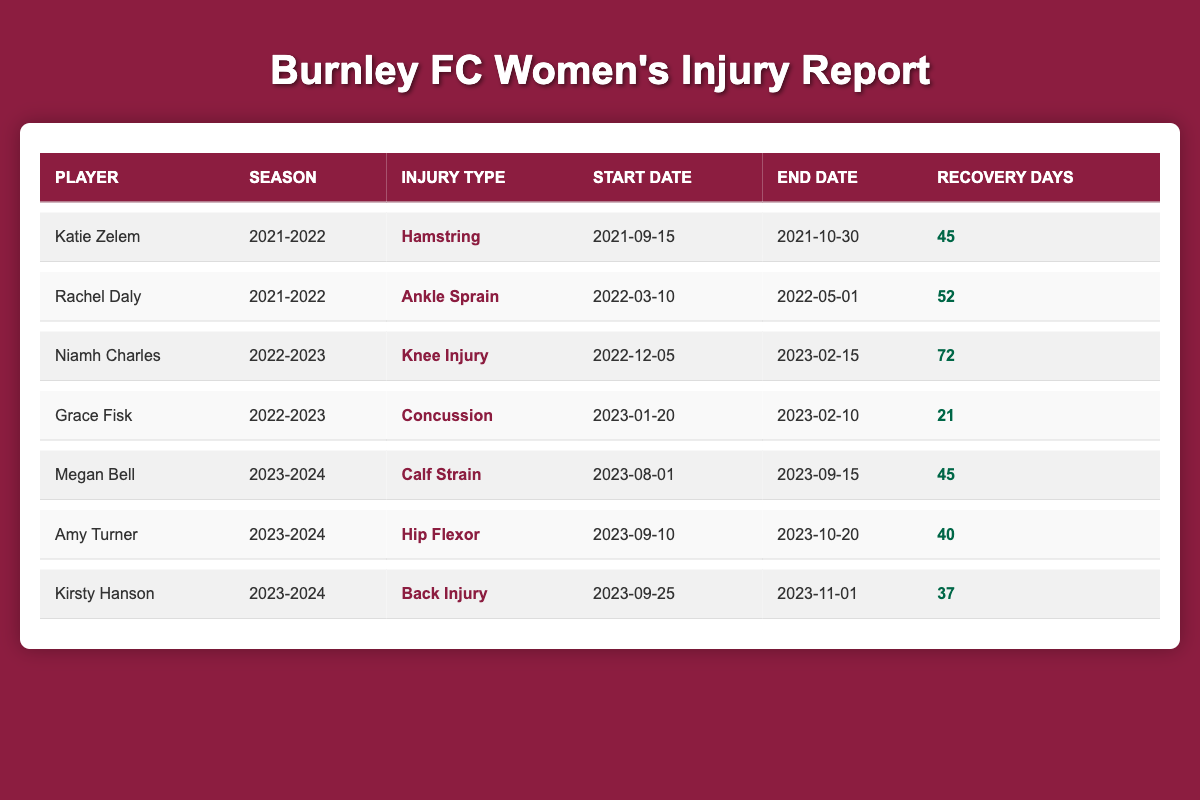What was the injury type for Niamh Charles in the 2022-2023 season? According to the table, Niamh Charles had a Knee Injury as noted under the "Injury Type" column for the 2022-2023 season.
Answer: Knee Injury How many recovery days did Amy Turner have for her injury? The table shows that Amy Turner had a total of 40 recovery days listed under the "Recovery Days" column for her Hip Flexor injury.
Answer: 40 Which player had the longest recovery time in the 2022-2023 season? Niamh Charles had 72 recovery days due to a Knee Injury, which is longer than any other player in the 2022-2023 season, making her the player with the longest recovery time.
Answer: Niamh Charles Is Rachel Daly's injury type classified as a sprain? Yes, Rachel Daly's injury type is mentioned in the table as "Ankle Sprain," which confirms that it is classified as a sprain.
Answer: Yes What is the total recovery time for all players from the 2023-2024 season? Adding the recovery days for all players in the 2023-2024 season: 45 (Megan Bell) + 40 (Amy Turner) + 37 (Kirsty Hanson) = 122, so the total recovery time is 122 days.
Answer: 122 What is the difference in recovery days between Katie Zelem and Rachel Daly? Katie Zelem had 45 recovery days while Rachel Daly had 52 recovery days. To find the difference, we subtract: 52 - 45 = 7 days.
Answer: 7 What was the average recovery time for the injuries listed in the 2021-2022 season? For the 2021-2022 season, the recovery days are 45 (Katie Zelem) and 52 (Rachel Daly). Adding both yields 97, and dividing by 2 gives 48.5 days as the average.
Answer: 48.5 Which player had a concussion injury and how many recovery days did they require? Grace Fisk had a concussion injury, and she required 21 recovery days according to the data laid out in the table.
Answer: Grace Fisk, 21 days What is the earliest start date for an injury listed in the table? The earliest start date listed in the table is September 15, 2021, for Katie Zelem's Hamstring injury. Hence, that's the earliest start date.
Answer: September 15, 2021 Based on the recovery times, who is expected to return to play first between Amy Turner and Kirsty Hanson? Amy Turner has 40 recovery days while Kirsty Hanson has 37 recovery days. Since 37 is less than 40, Kirsty Hanson is expected to return to play first based on their recovery times.
Answer: Kirsty Hanson 